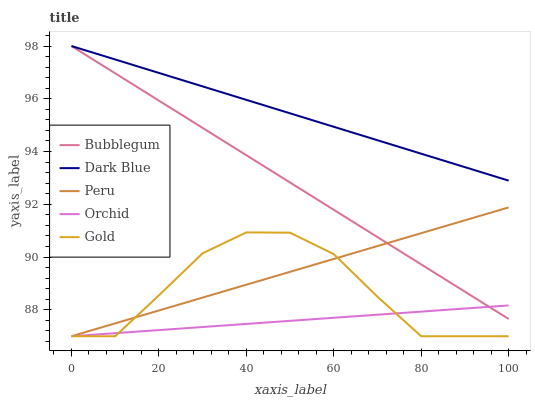Does Orchid have the minimum area under the curve?
Answer yes or no. Yes. Does Dark Blue have the maximum area under the curve?
Answer yes or no. Yes. Does Gold have the minimum area under the curve?
Answer yes or no. No. Does Gold have the maximum area under the curve?
Answer yes or no. No. Is Bubblegum the smoothest?
Answer yes or no. Yes. Is Gold the roughest?
Answer yes or no. Yes. Is Peru the smoothest?
Answer yes or no. No. Is Peru the roughest?
Answer yes or no. No. Does Gold have the lowest value?
Answer yes or no. Yes. Does Bubblegum have the lowest value?
Answer yes or no. No. Does Bubblegum have the highest value?
Answer yes or no. Yes. Does Gold have the highest value?
Answer yes or no. No. Is Gold less than Bubblegum?
Answer yes or no. Yes. Is Dark Blue greater than Orchid?
Answer yes or no. Yes. Does Orchid intersect Peru?
Answer yes or no. Yes. Is Orchid less than Peru?
Answer yes or no. No. Is Orchid greater than Peru?
Answer yes or no. No. Does Gold intersect Bubblegum?
Answer yes or no. No. 